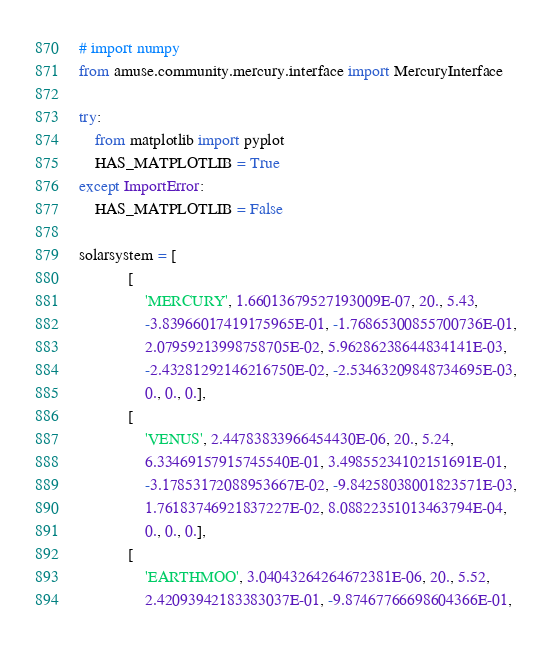<code> <loc_0><loc_0><loc_500><loc_500><_Python_># import numpy
from amuse.community.mercury.interface import MercuryInterface

try:
    from matplotlib import pyplot
    HAS_MATPLOTLIB = True
except ImportError:
    HAS_MATPLOTLIB = False

solarsystem = [
            [
                'MERCURY', 1.66013679527193009E-07, 20., 5.43,
                -3.83966017419175965E-01, -1.76865300855700736E-01,
                2.07959213998758705E-02, 5.96286238644834141E-03,
                -2.43281292146216750E-02, -2.53463209848734695E-03,
                0., 0., 0.],
            [
                'VENUS', 2.44783833966454430E-06, 20., 5.24,
                6.33469157915745540E-01, 3.49855234102151691E-01,
                -3.17853172088953667E-02, -9.84258038001823571E-03,
                1.76183746921837227E-02, 8.08822351013463794E-04,
                0., 0., 0.],
            [
                'EARTHMOO', 3.04043264264672381E-06, 20., 5.52,
                2.42093942183383037E-01, -9.87467766698604366E-01,</code> 